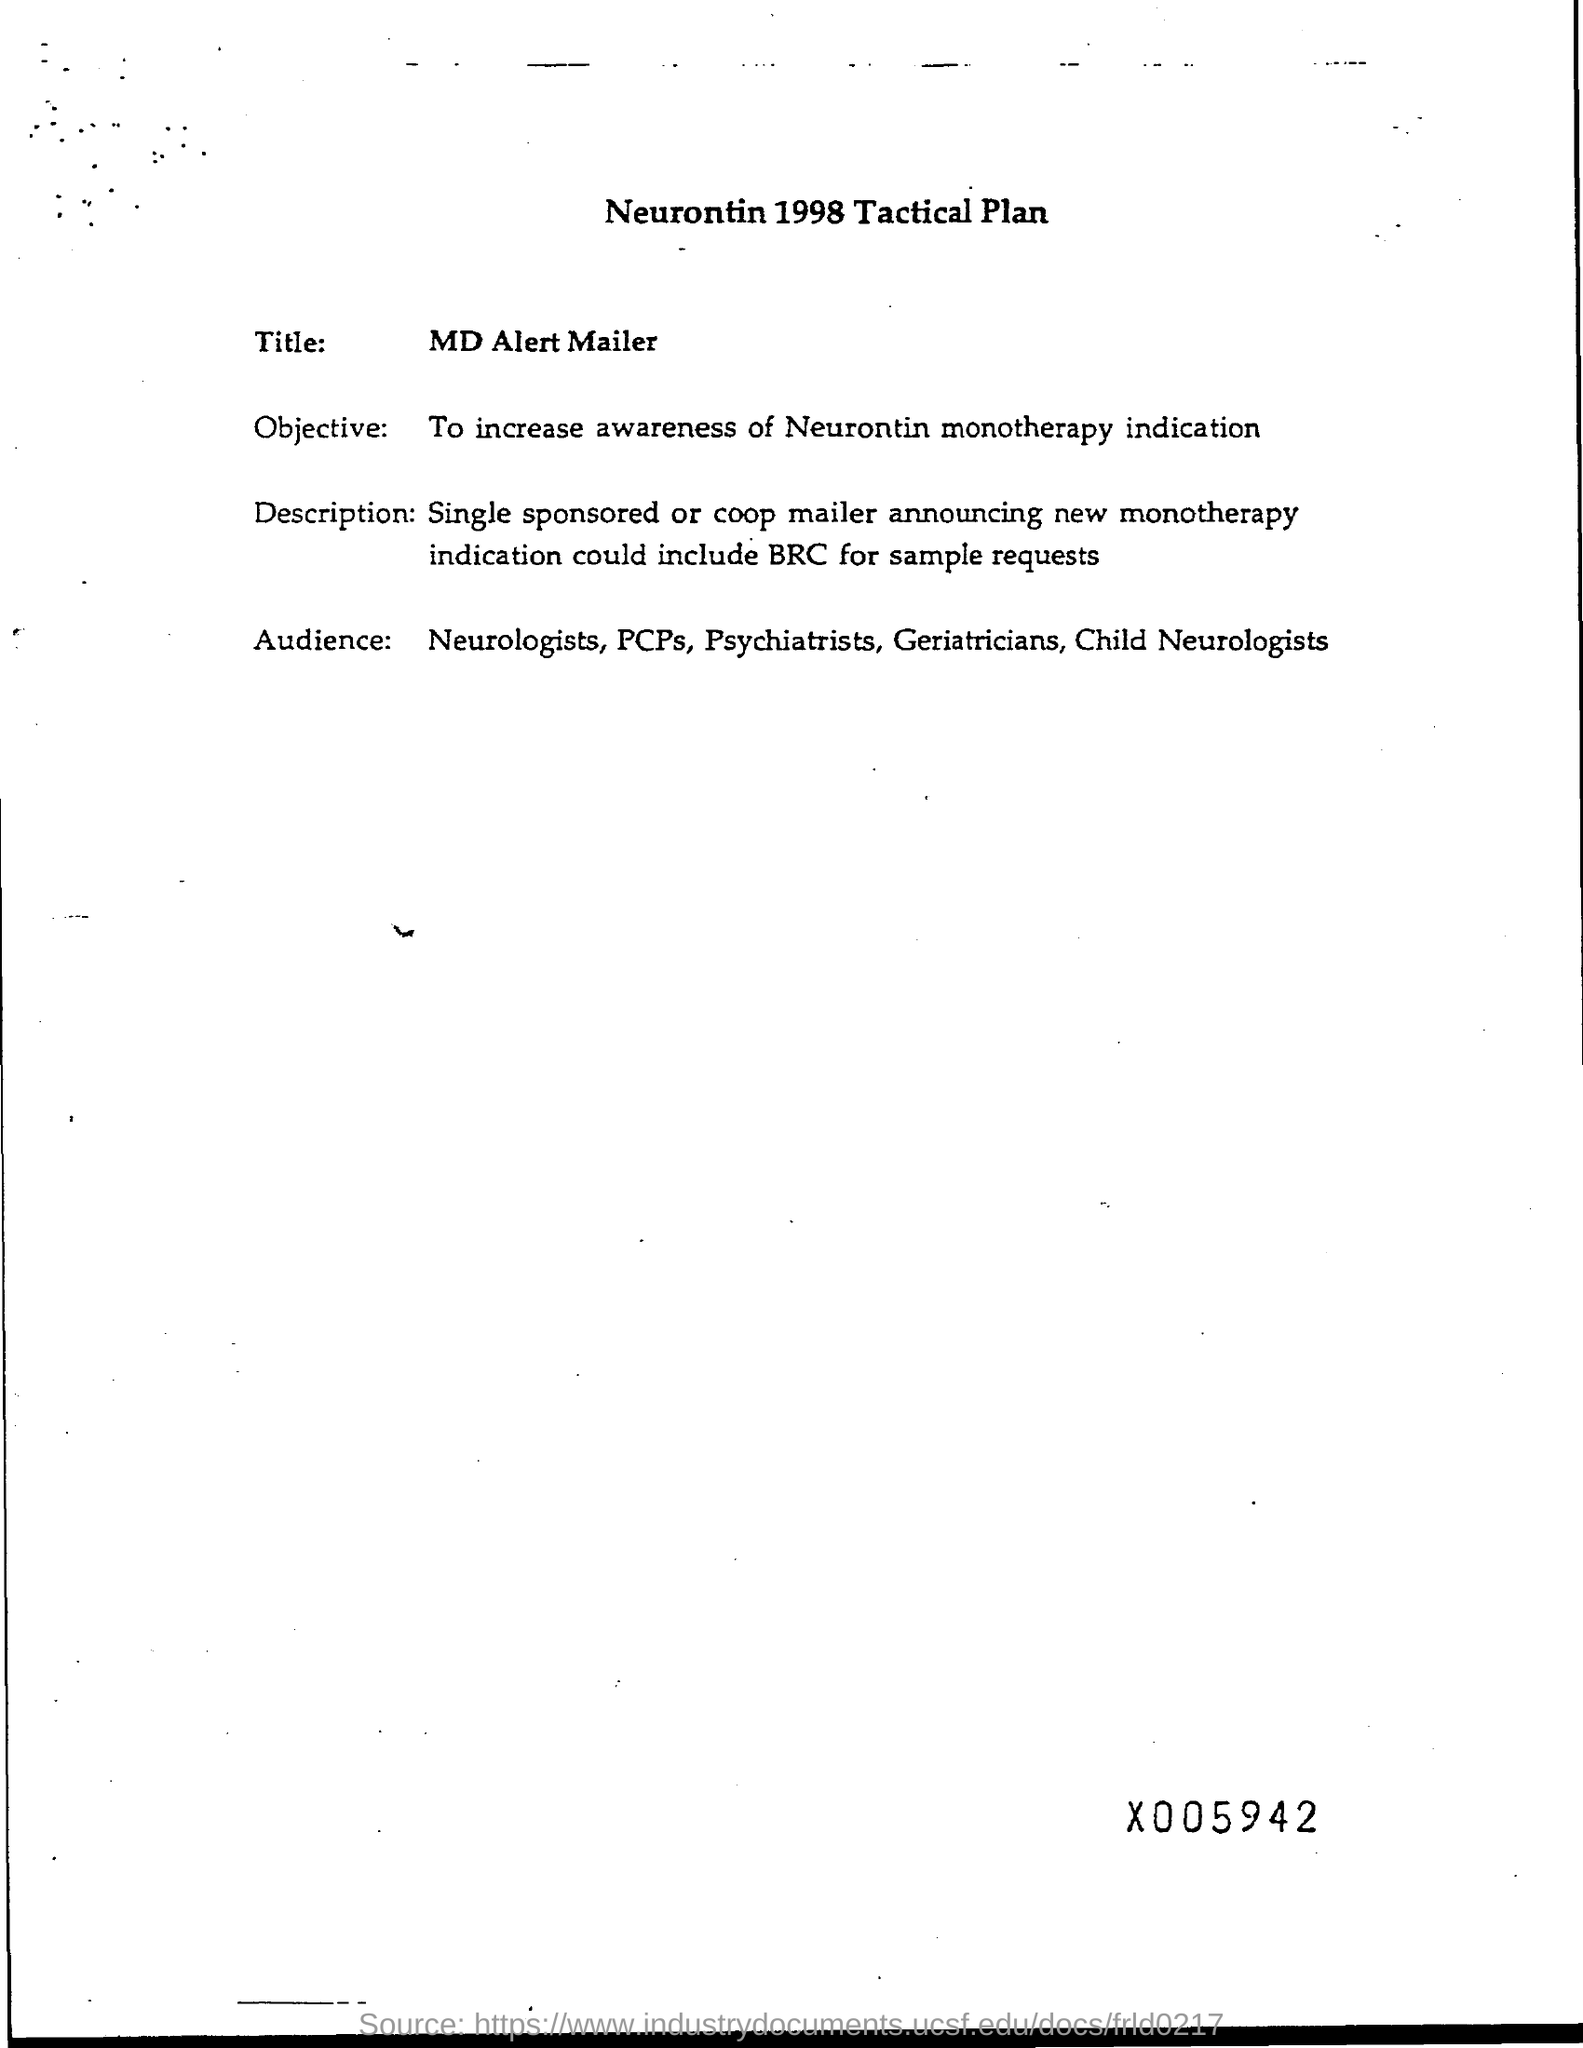Indicate a few pertinent items in this graphic. The document is titled 'What is the heading? NEURONTIN 1998 TACTICAL PLAN.' The objective is to increase awareness of the indication for Neurontin monotherapy. The title is MD ALERT MAILER. 